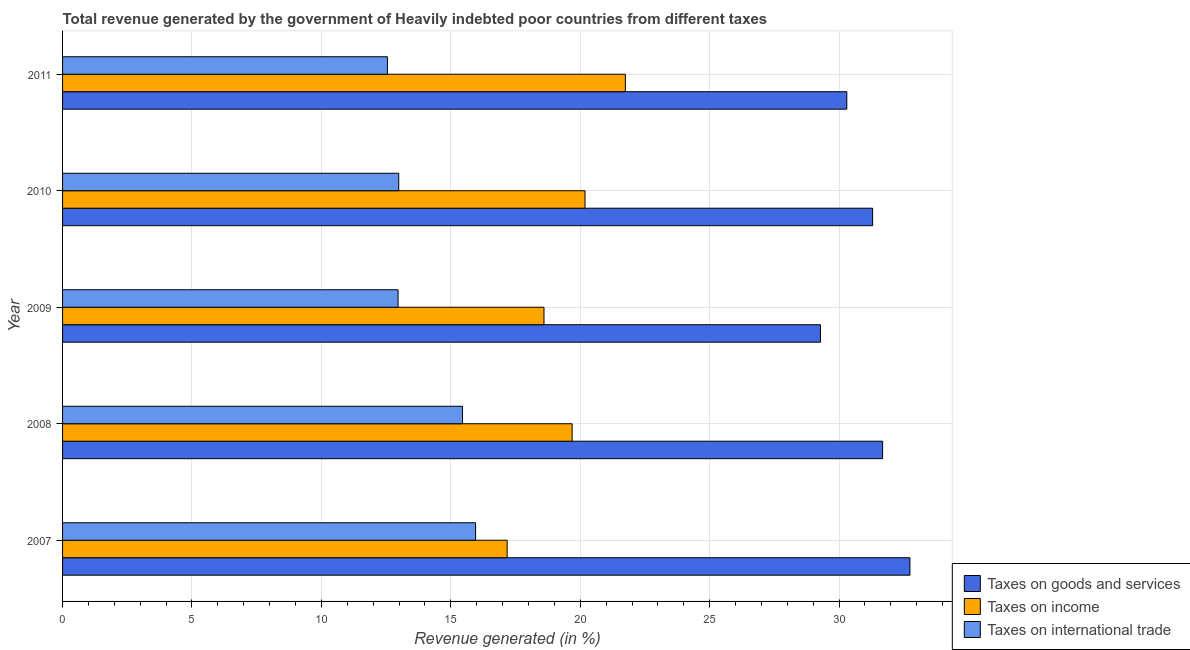How many different coloured bars are there?
Make the answer very short. 3. Are the number of bars on each tick of the Y-axis equal?
Your answer should be very brief. Yes. How many bars are there on the 3rd tick from the top?
Provide a succinct answer. 3. How many bars are there on the 4th tick from the bottom?
Your answer should be very brief. 3. What is the label of the 4th group of bars from the top?
Your response must be concise. 2008. What is the percentage of revenue generated by taxes on income in 2008?
Your answer should be compact. 19.69. Across all years, what is the maximum percentage of revenue generated by taxes on income?
Your response must be concise. 21.74. Across all years, what is the minimum percentage of revenue generated by taxes on goods and services?
Your answer should be very brief. 29.28. In which year was the percentage of revenue generated by tax on international trade maximum?
Make the answer very short. 2007. What is the total percentage of revenue generated by tax on international trade in the graph?
Offer a very short reply. 69.91. What is the difference between the percentage of revenue generated by taxes on income in 2008 and that in 2011?
Make the answer very short. -2.06. What is the difference between the percentage of revenue generated by taxes on income in 2007 and the percentage of revenue generated by taxes on goods and services in 2009?
Ensure brevity in your answer.  -12.1. What is the average percentage of revenue generated by taxes on income per year?
Make the answer very short. 19.48. In the year 2009, what is the difference between the percentage of revenue generated by taxes on income and percentage of revenue generated by tax on international trade?
Offer a terse response. 5.64. What is the ratio of the percentage of revenue generated by taxes on income in 2007 to that in 2008?
Your response must be concise. 0.87. Is the percentage of revenue generated by taxes on income in 2007 less than that in 2008?
Give a very brief answer. Yes. Is the difference between the percentage of revenue generated by taxes on income in 2007 and 2011 greater than the difference between the percentage of revenue generated by taxes on goods and services in 2007 and 2011?
Offer a very short reply. No. What is the difference between the highest and the second highest percentage of revenue generated by taxes on goods and services?
Ensure brevity in your answer.  1.05. What is the difference between the highest and the lowest percentage of revenue generated by tax on international trade?
Make the answer very short. 3.41. In how many years, is the percentage of revenue generated by tax on international trade greater than the average percentage of revenue generated by tax on international trade taken over all years?
Provide a short and direct response. 2. Is the sum of the percentage of revenue generated by taxes on goods and services in 2007 and 2009 greater than the maximum percentage of revenue generated by taxes on income across all years?
Give a very brief answer. Yes. What does the 2nd bar from the top in 2007 represents?
Give a very brief answer. Taxes on income. What does the 2nd bar from the bottom in 2008 represents?
Your answer should be very brief. Taxes on income. Are all the bars in the graph horizontal?
Provide a succinct answer. Yes. Are the values on the major ticks of X-axis written in scientific E-notation?
Your response must be concise. No. Does the graph contain any zero values?
Provide a succinct answer. No. Does the graph contain grids?
Ensure brevity in your answer.  Yes. How many legend labels are there?
Provide a succinct answer. 3. How are the legend labels stacked?
Offer a very short reply. Vertical. What is the title of the graph?
Give a very brief answer. Total revenue generated by the government of Heavily indebted poor countries from different taxes. What is the label or title of the X-axis?
Your answer should be very brief. Revenue generated (in %). What is the Revenue generated (in %) in Taxes on goods and services in 2007?
Offer a terse response. 32.74. What is the Revenue generated (in %) of Taxes on income in 2007?
Keep it short and to the point. 17.18. What is the Revenue generated (in %) of Taxes on international trade in 2007?
Keep it short and to the point. 15.96. What is the Revenue generated (in %) in Taxes on goods and services in 2008?
Your answer should be compact. 31.68. What is the Revenue generated (in %) in Taxes on income in 2008?
Keep it short and to the point. 19.69. What is the Revenue generated (in %) in Taxes on international trade in 2008?
Give a very brief answer. 15.45. What is the Revenue generated (in %) in Taxes on goods and services in 2009?
Your answer should be compact. 29.28. What is the Revenue generated (in %) of Taxes on income in 2009?
Provide a short and direct response. 18.6. What is the Revenue generated (in %) in Taxes on international trade in 2009?
Provide a succinct answer. 12.96. What is the Revenue generated (in %) in Taxes on goods and services in 2010?
Offer a very short reply. 31.3. What is the Revenue generated (in %) of Taxes on income in 2010?
Offer a terse response. 20.19. What is the Revenue generated (in %) in Taxes on international trade in 2010?
Make the answer very short. 12.99. What is the Revenue generated (in %) in Taxes on goods and services in 2011?
Ensure brevity in your answer.  30.3. What is the Revenue generated (in %) of Taxes on income in 2011?
Your response must be concise. 21.74. What is the Revenue generated (in %) of Taxes on international trade in 2011?
Make the answer very short. 12.55. Across all years, what is the maximum Revenue generated (in %) in Taxes on goods and services?
Make the answer very short. 32.74. Across all years, what is the maximum Revenue generated (in %) of Taxes on income?
Offer a terse response. 21.74. Across all years, what is the maximum Revenue generated (in %) in Taxes on international trade?
Keep it short and to the point. 15.96. Across all years, what is the minimum Revenue generated (in %) of Taxes on goods and services?
Your response must be concise. 29.28. Across all years, what is the minimum Revenue generated (in %) in Taxes on income?
Your answer should be compact. 17.18. Across all years, what is the minimum Revenue generated (in %) of Taxes on international trade?
Offer a very short reply. 12.55. What is the total Revenue generated (in %) in Taxes on goods and services in the graph?
Keep it short and to the point. 155.3. What is the total Revenue generated (in %) of Taxes on income in the graph?
Your response must be concise. 97.39. What is the total Revenue generated (in %) of Taxes on international trade in the graph?
Provide a succinct answer. 69.91. What is the difference between the Revenue generated (in %) in Taxes on goods and services in 2007 and that in 2008?
Your answer should be very brief. 1.05. What is the difference between the Revenue generated (in %) of Taxes on income in 2007 and that in 2008?
Your response must be concise. -2.51. What is the difference between the Revenue generated (in %) of Taxes on international trade in 2007 and that in 2008?
Offer a terse response. 0.51. What is the difference between the Revenue generated (in %) of Taxes on goods and services in 2007 and that in 2009?
Make the answer very short. 3.46. What is the difference between the Revenue generated (in %) in Taxes on income in 2007 and that in 2009?
Give a very brief answer. -1.42. What is the difference between the Revenue generated (in %) in Taxes on international trade in 2007 and that in 2009?
Your response must be concise. 2.99. What is the difference between the Revenue generated (in %) in Taxes on goods and services in 2007 and that in 2010?
Provide a short and direct response. 1.44. What is the difference between the Revenue generated (in %) of Taxes on income in 2007 and that in 2010?
Offer a very short reply. -3.01. What is the difference between the Revenue generated (in %) of Taxes on international trade in 2007 and that in 2010?
Your answer should be compact. 2.97. What is the difference between the Revenue generated (in %) in Taxes on goods and services in 2007 and that in 2011?
Offer a terse response. 2.44. What is the difference between the Revenue generated (in %) of Taxes on income in 2007 and that in 2011?
Provide a short and direct response. -4.57. What is the difference between the Revenue generated (in %) of Taxes on international trade in 2007 and that in 2011?
Your answer should be very brief. 3.41. What is the difference between the Revenue generated (in %) of Taxes on goods and services in 2008 and that in 2009?
Offer a very short reply. 2.4. What is the difference between the Revenue generated (in %) in Taxes on income in 2008 and that in 2009?
Give a very brief answer. 1.09. What is the difference between the Revenue generated (in %) in Taxes on international trade in 2008 and that in 2009?
Ensure brevity in your answer.  2.49. What is the difference between the Revenue generated (in %) in Taxes on goods and services in 2008 and that in 2010?
Give a very brief answer. 0.39. What is the difference between the Revenue generated (in %) of Taxes on income in 2008 and that in 2010?
Offer a very short reply. -0.5. What is the difference between the Revenue generated (in %) in Taxes on international trade in 2008 and that in 2010?
Your response must be concise. 2.46. What is the difference between the Revenue generated (in %) in Taxes on goods and services in 2008 and that in 2011?
Offer a terse response. 1.38. What is the difference between the Revenue generated (in %) in Taxes on income in 2008 and that in 2011?
Offer a terse response. -2.06. What is the difference between the Revenue generated (in %) in Taxes on international trade in 2008 and that in 2011?
Keep it short and to the point. 2.9. What is the difference between the Revenue generated (in %) of Taxes on goods and services in 2009 and that in 2010?
Ensure brevity in your answer.  -2.02. What is the difference between the Revenue generated (in %) of Taxes on income in 2009 and that in 2010?
Your answer should be compact. -1.59. What is the difference between the Revenue generated (in %) of Taxes on international trade in 2009 and that in 2010?
Provide a short and direct response. -0.03. What is the difference between the Revenue generated (in %) of Taxes on goods and services in 2009 and that in 2011?
Make the answer very short. -1.02. What is the difference between the Revenue generated (in %) of Taxes on income in 2009 and that in 2011?
Keep it short and to the point. -3.14. What is the difference between the Revenue generated (in %) in Taxes on international trade in 2009 and that in 2011?
Your answer should be compact. 0.41. What is the difference between the Revenue generated (in %) in Taxes on goods and services in 2010 and that in 2011?
Provide a short and direct response. 1. What is the difference between the Revenue generated (in %) in Taxes on income in 2010 and that in 2011?
Give a very brief answer. -1.56. What is the difference between the Revenue generated (in %) of Taxes on international trade in 2010 and that in 2011?
Offer a very short reply. 0.44. What is the difference between the Revenue generated (in %) in Taxes on goods and services in 2007 and the Revenue generated (in %) in Taxes on income in 2008?
Your answer should be very brief. 13.05. What is the difference between the Revenue generated (in %) of Taxes on goods and services in 2007 and the Revenue generated (in %) of Taxes on international trade in 2008?
Provide a succinct answer. 17.29. What is the difference between the Revenue generated (in %) in Taxes on income in 2007 and the Revenue generated (in %) in Taxes on international trade in 2008?
Ensure brevity in your answer.  1.73. What is the difference between the Revenue generated (in %) of Taxes on goods and services in 2007 and the Revenue generated (in %) of Taxes on income in 2009?
Provide a succinct answer. 14.14. What is the difference between the Revenue generated (in %) of Taxes on goods and services in 2007 and the Revenue generated (in %) of Taxes on international trade in 2009?
Offer a terse response. 19.78. What is the difference between the Revenue generated (in %) of Taxes on income in 2007 and the Revenue generated (in %) of Taxes on international trade in 2009?
Make the answer very short. 4.21. What is the difference between the Revenue generated (in %) in Taxes on goods and services in 2007 and the Revenue generated (in %) in Taxes on income in 2010?
Make the answer very short. 12.55. What is the difference between the Revenue generated (in %) of Taxes on goods and services in 2007 and the Revenue generated (in %) of Taxes on international trade in 2010?
Ensure brevity in your answer.  19.75. What is the difference between the Revenue generated (in %) of Taxes on income in 2007 and the Revenue generated (in %) of Taxes on international trade in 2010?
Keep it short and to the point. 4.19. What is the difference between the Revenue generated (in %) in Taxes on goods and services in 2007 and the Revenue generated (in %) in Taxes on income in 2011?
Your answer should be compact. 10.99. What is the difference between the Revenue generated (in %) in Taxes on goods and services in 2007 and the Revenue generated (in %) in Taxes on international trade in 2011?
Your answer should be very brief. 20.19. What is the difference between the Revenue generated (in %) in Taxes on income in 2007 and the Revenue generated (in %) in Taxes on international trade in 2011?
Your response must be concise. 4.63. What is the difference between the Revenue generated (in %) in Taxes on goods and services in 2008 and the Revenue generated (in %) in Taxes on income in 2009?
Make the answer very short. 13.08. What is the difference between the Revenue generated (in %) in Taxes on goods and services in 2008 and the Revenue generated (in %) in Taxes on international trade in 2009?
Your response must be concise. 18.72. What is the difference between the Revenue generated (in %) in Taxes on income in 2008 and the Revenue generated (in %) in Taxes on international trade in 2009?
Offer a terse response. 6.72. What is the difference between the Revenue generated (in %) of Taxes on goods and services in 2008 and the Revenue generated (in %) of Taxes on income in 2010?
Offer a terse response. 11.5. What is the difference between the Revenue generated (in %) of Taxes on goods and services in 2008 and the Revenue generated (in %) of Taxes on international trade in 2010?
Offer a very short reply. 18.69. What is the difference between the Revenue generated (in %) of Taxes on income in 2008 and the Revenue generated (in %) of Taxes on international trade in 2010?
Keep it short and to the point. 6.7. What is the difference between the Revenue generated (in %) in Taxes on goods and services in 2008 and the Revenue generated (in %) in Taxes on income in 2011?
Ensure brevity in your answer.  9.94. What is the difference between the Revenue generated (in %) in Taxes on goods and services in 2008 and the Revenue generated (in %) in Taxes on international trade in 2011?
Keep it short and to the point. 19.13. What is the difference between the Revenue generated (in %) of Taxes on income in 2008 and the Revenue generated (in %) of Taxes on international trade in 2011?
Offer a terse response. 7.14. What is the difference between the Revenue generated (in %) in Taxes on goods and services in 2009 and the Revenue generated (in %) in Taxes on income in 2010?
Give a very brief answer. 9.1. What is the difference between the Revenue generated (in %) in Taxes on goods and services in 2009 and the Revenue generated (in %) in Taxes on international trade in 2010?
Keep it short and to the point. 16.29. What is the difference between the Revenue generated (in %) in Taxes on income in 2009 and the Revenue generated (in %) in Taxes on international trade in 2010?
Offer a very short reply. 5.61. What is the difference between the Revenue generated (in %) in Taxes on goods and services in 2009 and the Revenue generated (in %) in Taxes on income in 2011?
Provide a succinct answer. 7.54. What is the difference between the Revenue generated (in %) of Taxes on goods and services in 2009 and the Revenue generated (in %) of Taxes on international trade in 2011?
Make the answer very short. 16.73. What is the difference between the Revenue generated (in %) in Taxes on income in 2009 and the Revenue generated (in %) in Taxes on international trade in 2011?
Your answer should be compact. 6.05. What is the difference between the Revenue generated (in %) of Taxes on goods and services in 2010 and the Revenue generated (in %) of Taxes on income in 2011?
Give a very brief answer. 9.55. What is the difference between the Revenue generated (in %) in Taxes on goods and services in 2010 and the Revenue generated (in %) in Taxes on international trade in 2011?
Your response must be concise. 18.75. What is the difference between the Revenue generated (in %) in Taxes on income in 2010 and the Revenue generated (in %) in Taxes on international trade in 2011?
Your response must be concise. 7.63. What is the average Revenue generated (in %) in Taxes on goods and services per year?
Keep it short and to the point. 31.06. What is the average Revenue generated (in %) of Taxes on income per year?
Make the answer very short. 19.48. What is the average Revenue generated (in %) in Taxes on international trade per year?
Give a very brief answer. 13.98. In the year 2007, what is the difference between the Revenue generated (in %) in Taxes on goods and services and Revenue generated (in %) in Taxes on income?
Offer a very short reply. 15.56. In the year 2007, what is the difference between the Revenue generated (in %) in Taxes on goods and services and Revenue generated (in %) in Taxes on international trade?
Give a very brief answer. 16.78. In the year 2007, what is the difference between the Revenue generated (in %) in Taxes on income and Revenue generated (in %) in Taxes on international trade?
Offer a very short reply. 1.22. In the year 2008, what is the difference between the Revenue generated (in %) of Taxes on goods and services and Revenue generated (in %) of Taxes on income?
Your answer should be compact. 12. In the year 2008, what is the difference between the Revenue generated (in %) of Taxes on goods and services and Revenue generated (in %) of Taxes on international trade?
Offer a terse response. 16.23. In the year 2008, what is the difference between the Revenue generated (in %) in Taxes on income and Revenue generated (in %) in Taxes on international trade?
Your answer should be compact. 4.24. In the year 2009, what is the difference between the Revenue generated (in %) of Taxes on goods and services and Revenue generated (in %) of Taxes on income?
Give a very brief answer. 10.68. In the year 2009, what is the difference between the Revenue generated (in %) in Taxes on goods and services and Revenue generated (in %) in Taxes on international trade?
Make the answer very short. 16.32. In the year 2009, what is the difference between the Revenue generated (in %) in Taxes on income and Revenue generated (in %) in Taxes on international trade?
Provide a succinct answer. 5.64. In the year 2010, what is the difference between the Revenue generated (in %) in Taxes on goods and services and Revenue generated (in %) in Taxes on income?
Offer a very short reply. 11.11. In the year 2010, what is the difference between the Revenue generated (in %) in Taxes on goods and services and Revenue generated (in %) in Taxes on international trade?
Provide a succinct answer. 18.31. In the year 2010, what is the difference between the Revenue generated (in %) of Taxes on income and Revenue generated (in %) of Taxes on international trade?
Make the answer very short. 7.2. In the year 2011, what is the difference between the Revenue generated (in %) in Taxes on goods and services and Revenue generated (in %) in Taxes on income?
Provide a short and direct response. 8.56. In the year 2011, what is the difference between the Revenue generated (in %) in Taxes on goods and services and Revenue generated (in %) in Taxes on international trade?
Your response must be concise. 17.75. In the year 2011, what is the difference between the Revenue generated (in %) of Taxes on income and Revenue generated (in %) of Taxes on international trade?
Your answer should be compact. 9.19. What is the ratio of the Revenue generated (in %) in Taxes on income in 2007 to that in 2008?
Make the answer very short. 0.87. What is the ratio of the Revenue generated (in %) of Taxes on international trade in 2007 to that in 2008?
Your answer should be very brief. 1.03. What is the ratio of the Revenue generated (in %) in Taxes on goods and services in 2007 to that in 2009?
Your answer should be very brief. 1.12. What is the ratio of the Revenue generated (in %) of Taxes on income in 2007 to that in 2009?
Your response must be concise. 0.92. What is the ratio of the Revenue generated (in %) of Taxes on international trade in 2007 to that in 2009?
Provide a short and direct response. 1.23. What is the ratio of the Revenue generated (in %) of Taxes on goods and services in 2007 to that in 2010?
Keep it short and to the point. 1.05. What is the ratio of the Revenue generated (in %) of Taxes on income in 2007 to that in 2010?
Offer a very short reply. 0.85. What is the ratio of the Revenue generated (in %) of Taxes on international trade in 2007 to that in 2010?
Provide a succinct answer. 1.23. What is the ratio of the Revenue generated (in %) in Taxes on goods and services in 2007 to that in 2011?
Provide a succinct answer. 1.08. What is the ratio of the Revenue generated (in %) of Taxes on income in 2007 to that in 2011?
Give a very brief answer. 0.79. What is the ratio of the Revenue generated (in %) of Taxes on international trade in 2007 to that in 2011?
Keep it short and to the point. 1.27. What is the ratio of the Revenue generated (in %) of Taxes on goods and services in 2008 to that in 2009?
Provide a succinct answer. 1.08. What is the ratio of the Revenue generated (in %) in Taxes on income in 2008 to that in 2009?
Your answer should be compact. 1.06. What is the ratio of the Revenue generated (in %) in Taxes on international trade in 2008 to that in 2009?
Provide a short and direct response. 1.19. What is the ratio of the Revenue generated (in %) of Taxes on goods and services in 2008 to that in 2010?
Ensure brevity in your answer.  1.01. What is the ratio of the Revenue generated (in %) of Taxes on income in 2008 to that in 2010?
Your answer should be very brief. 0.98. What is the ratio of the Revenue generated (in %) of Taxes on international trade in 2008 to that in 2010?
Provide a succinct answer. 1.19. What is the ratio of the Revenue generated (in %) of Taxes on goods and services in 2008 to that in 2011?
Your answer should be compact. 1.05. What is the ratio of the Revenue generated (in %) in Taxes on income in 2008 to that in 2011?
Provide a succinct answer. 0.91. What is the ratio of the Revenue generated (in %) of Taxes on international trade in 2008 to that in 2011?
Your response must be concise. 1.23. What is the ratio of the Revenue generated (in %) in Taxes on goods and services in 2009 to that in 2010?
Make the answer very short. 0.94. What is the ratio of the Revenue generated (in %) in Taxes on income in 2009 to that in 2010?
Your answer should be compact. 0.92. What is the ratio of the Revenue generated (in %) of Taxes on goods and services in 2009 to that in 2011?
Keep it short and to the point. 0.97. What is the ratio of the Revenue generated (in %) in Taxes on income in 2009 to that in 2011?
Make the answer very short. 0.86. What is the ratio of the Revenue generated (in %) in Taxes on international trade in 2009 to that in 2011?
Offer a terse response. 1.03. What is the ratio of the Revenue generated (in %) of Taxes on goods and services in 2010 to that in 2011?
Ensure brevity in your answer.  1.03. What is the ratio of the Revenue generated (in %) in Taxes on income in 2010 to that in 2011?
Your answer should be compact. 0.93. What is the ratio of the Revenue generated (in %) in Taxes on international trade in 2010 to that in 2011?
Give a very brief answer. 1.03. What is the difference between the highest and the second highest Revenue generated (in %) in Taxes on goods and services?
Ensure brevity in your answer.  1.05. What is the difference between the highest and the second highest Revenue generated (in %) in Taxes on income?
Provide a short and direct response. 1.56. What is the difference between the highest and the second highest Revenue generated (in %) of Taxes on international trade?
Give a very brief answer. 0.51. What is the difference between the highest and the lowest Revenue generated (in %) of Taxes on goods and services?
Your answer should be very brief. 3.46. What is the difference between the highest and the lowest Revenue generated (in %) of Taxes on income?
Provide a short and direct response. 4.57. What is the difference between the highest and the lowest Revenue generated (in %) in Taxes on international trade?
Keep it short and to the point. 3.41. 